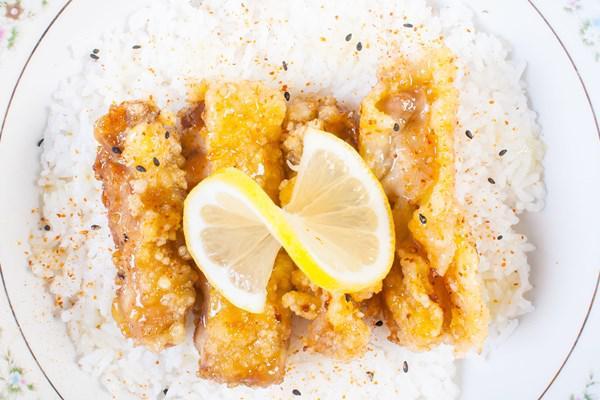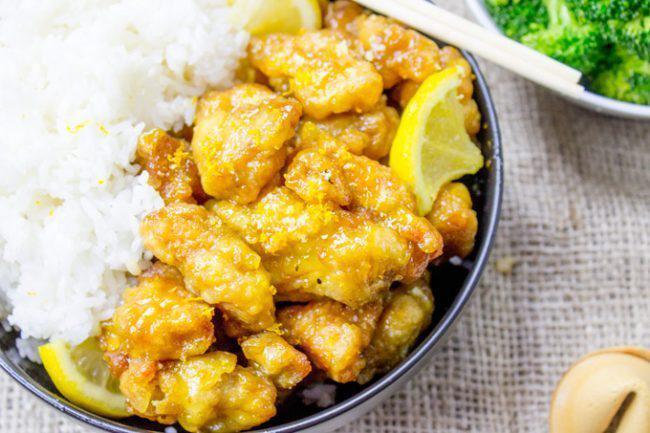The first image is the image on the left, the second image is the image on the right. For the images displayed, is the sentence "The lemon slices are on top of meat in at least one of the images." factually correct? Answer yes or no. Yes. The first image is the image on the left, the second image is the image on the right. For the images displayed, is the sentence "There is a whole lemon in exactly one of the images." factually correct? Answer yes or no. No. 